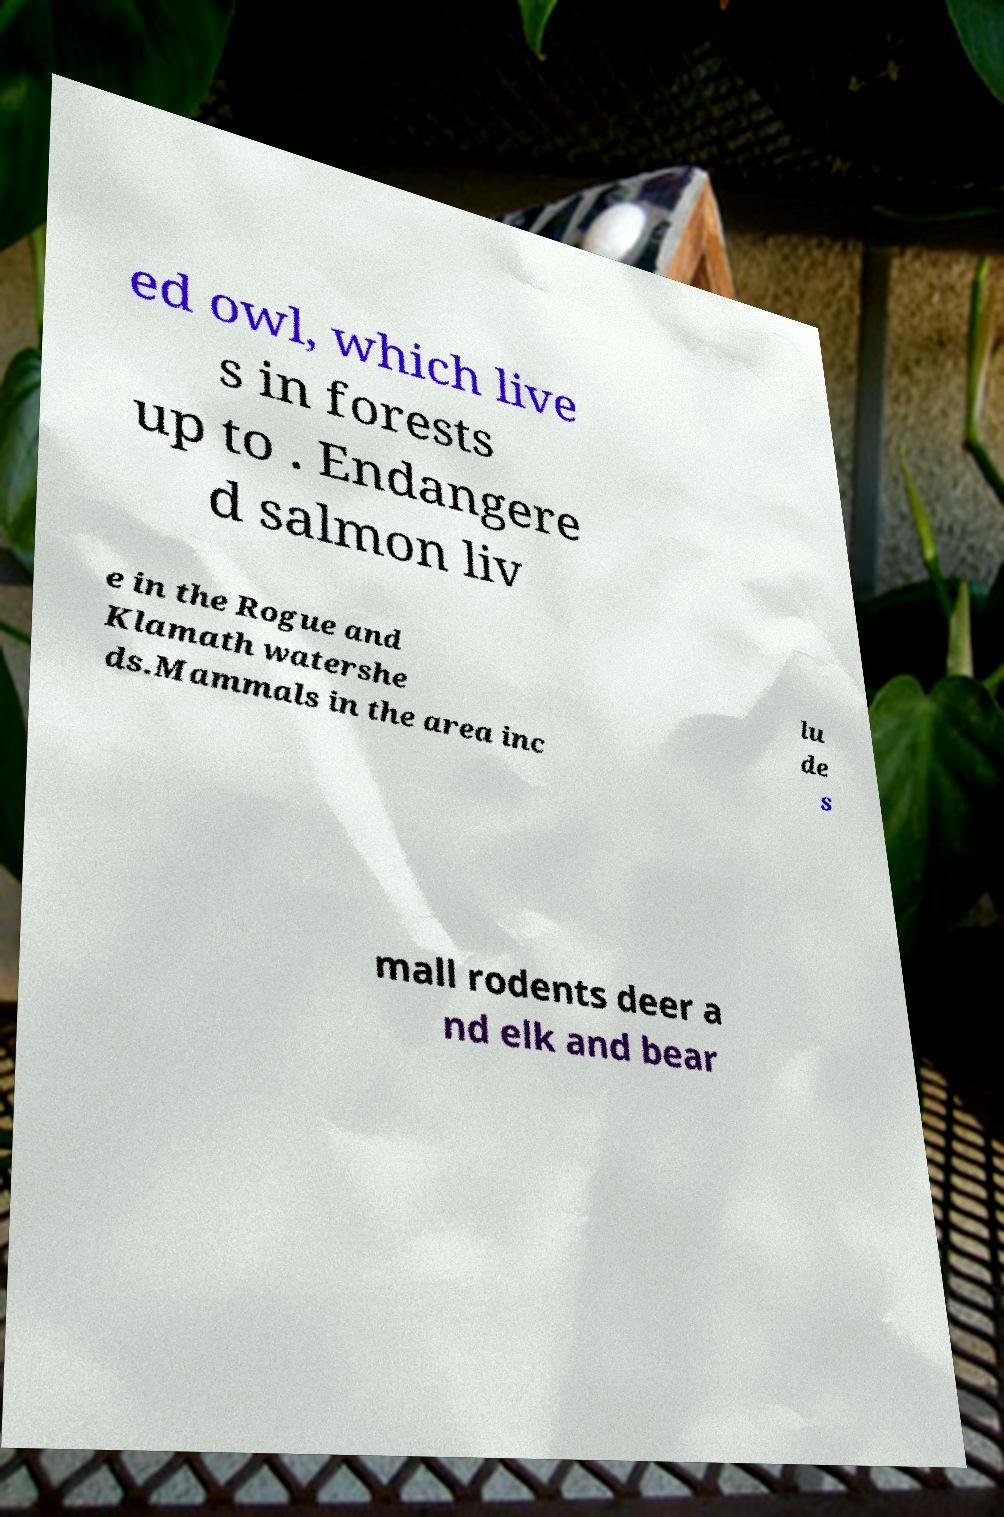What messages or text are displayed in this image? I need them in a readable, typed format. ed owl, which live s in forests up to . Endangere d salmon liv e in the Rogue and Klamath watershe ds.Mammals in the area inc lu de s mall rodents deer a nd elk and bear 